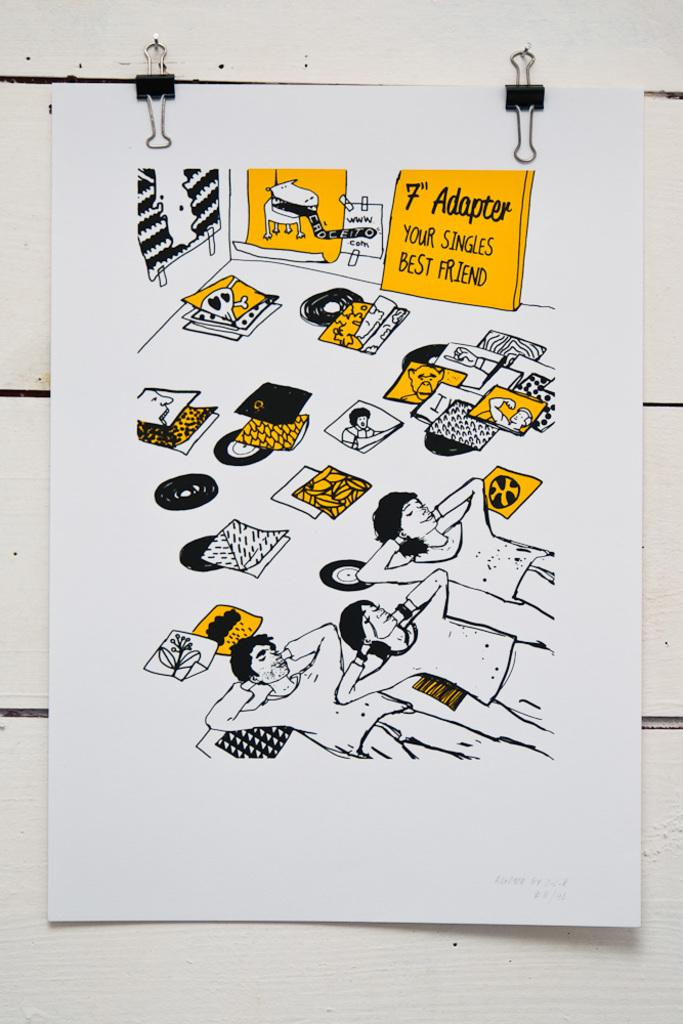What is on the white wall in the image? There is a poster on a white wall in the image. How is the poster attached to the wall? The poster has clips. What can be seen on the poster? The poster contains images, people, and figures. Who is the expert in the poster? There is no mention of an expert in the image or the poster. The poster contains images, people, and figures, but it does not specify any expertise or roles for the individuals depicted. 